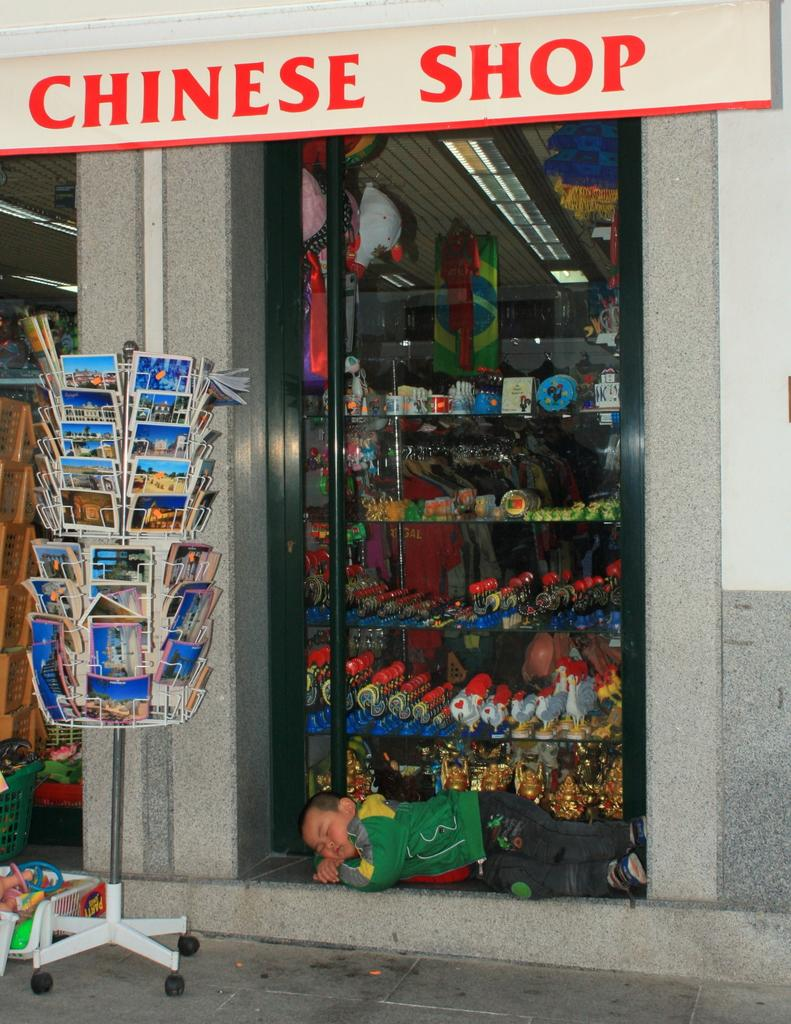<image>
Render a clear and concise summary of the photo. the outside of a shop that has a sign on it that says 'chinese shop' 